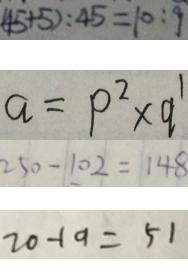Convert formula to latex. <formula><loc_0><loc_0><loc_500><loc_500>( 4 5 + 5 ) : 4 5 = 1 0 : 9 
 a = p ^ { 2 } \times q ^ { 1 } 
 2 5 0 - 1 0 2 = 1 4 8 
 7 0 - 1 9 = 5 1</formula> 